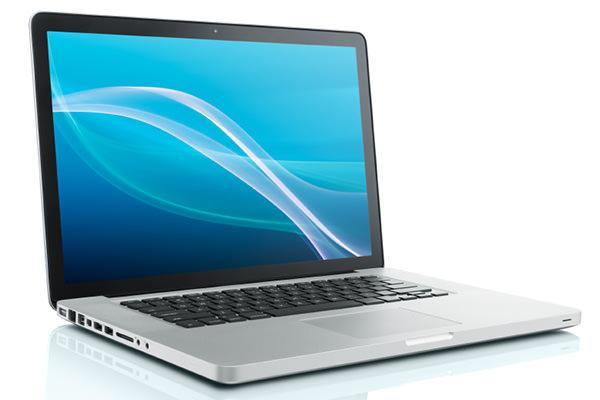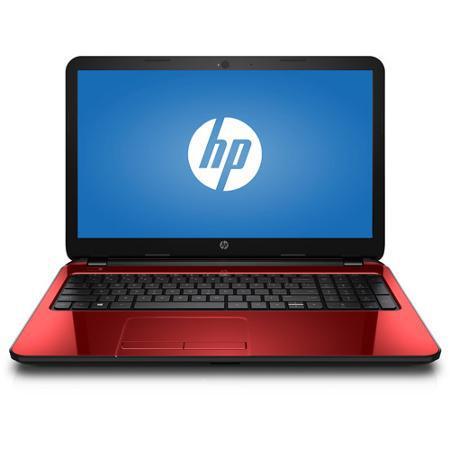The first image is the image on the left, the second image is the image on the right. For the images shown, is this caption "There are five laptops" true? Answer yes or no. No. The first image is the image on the left, the second image is the image on the right. Evaluate the accuracy of this statement regarding the images: "The lids of all laptop computers are fully upright.". Is it true? Answer yes or no. Yes. 